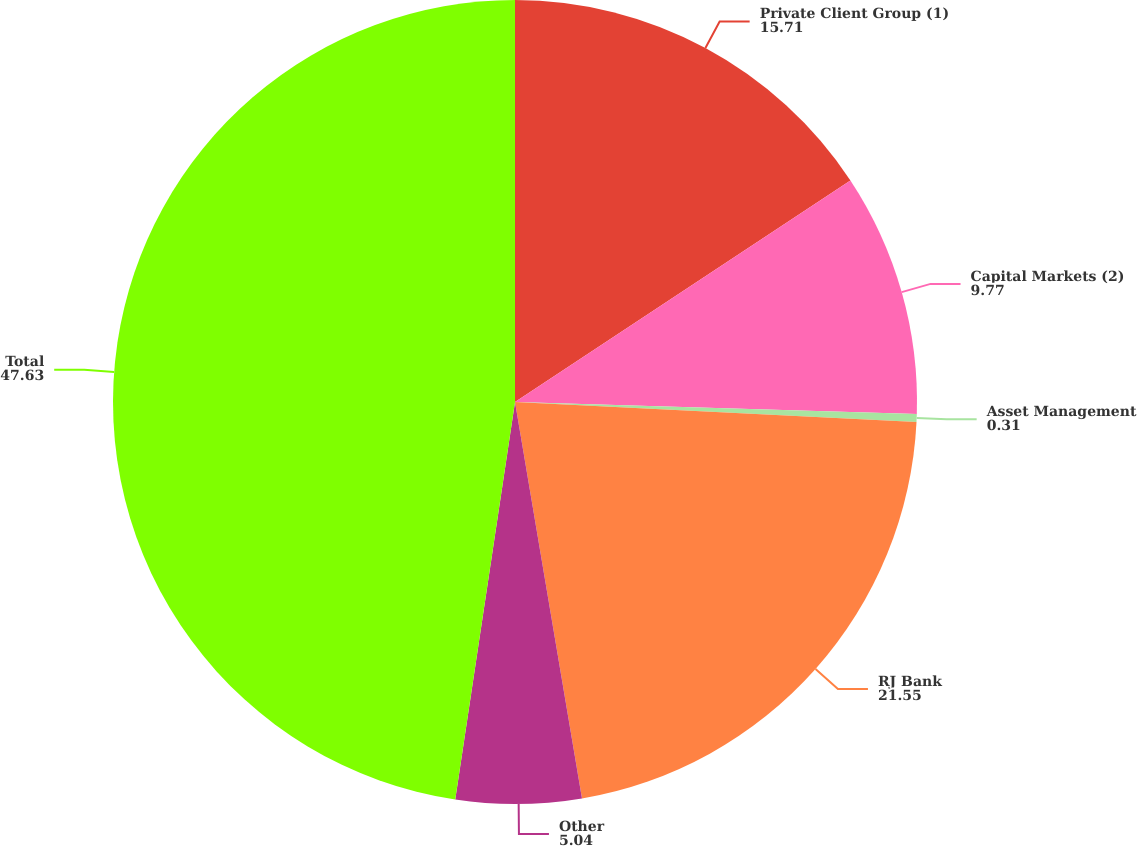Convert chart to OTSL. <chart><loc_0><loc_0><loc_500><loc_500><pie_chart><fcel>Private Client Group (1)<fcel>Capital Markets (2)<fcel>Asset Management<fcel>RJ Bank<fcel>Other<fcel>Total<nl><fcel>15.71%<fcel>9.77%<fcel>0.31%<fcel>21.55%<fcel>5.04%<fcel>47.63%<nl></chart> 